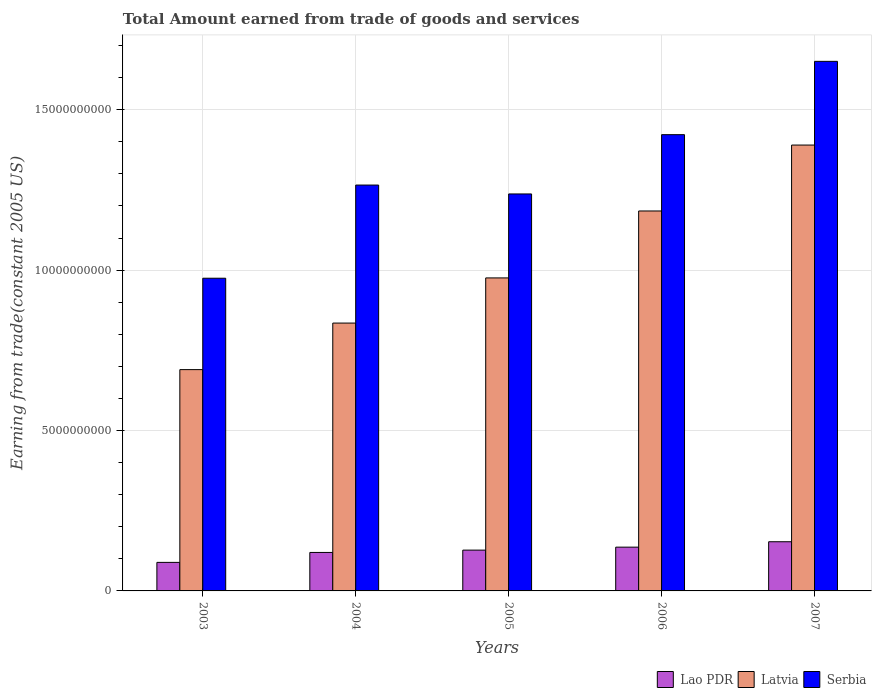How many different coloured bars are there?
Keep it short and to the point. 3. Are the number of bars on each tick of the X-axis equal?
Keep it short and to the point. Yes. How many bars are there on the 3rd tick from the left?
Give a very brief answer. 3. What is the total amount earned by trading goods and services in Serbia in 2003?
Your answer should be very brief. 9.75e+09. Across all years, what is the maximum total amount earned by trading goods and services in Latvia?
Give a very brief answer. 1.39e+1. Across all years, what is the minimum total amount earned by trading goods and services in Lao PDR?
Provide a succinct answer. 8.90e+08. What is the total total amount earned by trading goods and services in Latvia in the graph?
Give a very brief answer. 5.07e+1. What is the difference between the total amount earned by trading goods and services in Lao PDR in 2006 and that in 2007?
Provide a succinct answer. -1.69e+08. What is the difference between the total amount earned by trading goods and services in Serbia in 2007 and the total amount earned by trading goods and services in Latvia in 2003?
Make the answer very short. 9.61e+09. What is the average total amount earned by trading goods and services in Latvia per year?
Your answer should be very brief. 1.01e+1. In the year 2003, what is the difference between the total amount earned by trading goods and services in Latvia and total amount earned by trading goods and services in Serbia?
Give a very brief answer. -2.85e+09. What is the ratio of the total amount earned by trading goods and services in Lao PDR in 2003 to that in 2006?
Make the answer very short. 0.65. Is the total amount earned by trading goods and services in Serbia in 2004 less than that in 2006?
Your answer should be compact. Yes. Is the difference between the total amount earned by trading goods and services in Latvia in 2004 and 2005 greater than the difference between the total amount earned by trading goods and services in Serbia in 2004 and 2005?
Ensure brevity in your answer.  No. What is the difference between the highest and the second highest total amount earned by trading goods and services in Latvia?
Give a very brief answer. 2.05e+09. What is the difference between the highest and the lowest total amount earned by trading goods and services in Serbia?
Make the answer very short. 6.76e+09. In how many years, is the total amount earned by trading goods and services in Latvia greater than the average total amount earned by trading goods and services in Latvia taken over all years?
Offer a very short reply. 2. What does the 3rd bar from the left in 2004 represents?
Provide a short and direct response. Serbia. What does the 2nd bar from the right in 2007 represents?
Ensure brevity in your answer.  Latvia. Is it the case that in every year, the sum of the total amount earned by trading goods and services in Latvia and total amount earned by trading goods and services in Serbia is greater than the total amount earned by trading goods and services in Lao PDR?
Provide a succinct answer. Yes. How many bars are there?
Your answer should be very brief. 15. Are all the bars in the graph horizontal?
Your answer should be very brief. No. How many years are there in the graph?
Offer a very short reply. 5. What is the difference between two consecutive major ticks on the Y-axis?
Ensure brevity in your answer.  5.00e+09. Does the graph contain grids?
Give a very brief answer. Yes. What is the title of the graph?
Your response must be concise. Total Amount earned from trade of goods and services. What is the label or title of the Y-axis?
Provide a short and direct response. Earning from trade(constant 2005 US). What is the Earning from trade(constant 2005 US) of Lao PDR in 2003?
Provide a short and direct response. 8.90e+08. What is the Earning from trade(constant 2005 US) in Latvia in 2003?
Provide a short and direct response. 6.90e+09. What is the Earning from trade(constant 2005 US) of Serbia in 2003?
Give a very brief answer. 9.75e+09. What is the Earning from trade(constant 2005 US) in Lao PDR in 2004?
Keep it short and to the point. 1.20e+09. What is the Earning from trade(constant 2005 US) in Latvia in 2004?
Offer a very short reply. 8.35e+09. What is the Earning from trade(constant 2005 US) in Serbia in 2004?
Offer a terse response. 1.27e+1. What is the Earning from trade(constant 2005 US) in Lao PDR in 2005?
Provide a short and direct response. 1.27e+09. What is the Earning from trade(constant 2005 US) in Latvia in 2005?
Your answer should be compact. 9.76e+09. What is the Earning from trade(constant 2005 US) of Serbia in 2005?
Provide a short and direct response. 1.24e+1. What is the Earning from trade(constant 2005 US) of Lao PDR in 2006?
Your response must be concise. 1.36e+09. What is the Earning from trade(constant 2005 US) of Latvia in 2006?
Offer a terse response. 1.18e+1. What is the Earning from trade(constant 2005 US) of Serbia in 2006?
Offer a very short reply. 1.42e+1. What is the Earning from trade(constant 2005 US) of Lao PDR in 2007?
Make the answer very short. 1.53e+09. What is the Earning from trade(constant 2005 US) in Latvia in 2007?
Offer a terse response. 1.39e+1. What is the Earning from trade(constant 2005 US) of Serbia in 2007?
Make the answer very short. 1.65e+1. Across all years, what is the maximum Earning from trade(constant 2005 US) of Lao PDR?
Keep it short and to the point. 1.53e+09. Across all years, what is the maximum Earning from trade(constant 2005 US) of Latvia?
Your answer should be very brief. 1.39e+1. Across all years, what is the maximum Earning from trade(constant 2005 US) of Serbia?
Offer a terse response. 1.65e+1. Across all years, what is the minimum Earning from trade(constant 2005 US) of Lao PDR?
Your response must be concise. 8.90e+08. Across all years, what is the minimum Earning from trade(constant 2005 US) in Latvia?
Offer a very short reply. 6.90e+09. Across all years, what is the minimum Earning from trade(constant 2005 US) in Serbia?
Offer a terse response. 9.75e+09. What is the total Earning from trade(constant 2005 US) in Lao PDR in the graph?
Give a very brief answer. 6.26e+09. What is the total Earning from trade(constant 2005 US) of Latvia in the graph?
Give a very brief answer. 5.07e+1. What is the total Earning from trade(constant 2005 US) in Serbia in the graph?
Your answer should be very brief. 6.55e+1. What is the difference between the Earning from trade(constant 2005 US) of Lao PDR in 2003 and that in 2004?
Provide a short and direct response. -3.10e+08. What is the difference between the Earning from trade(constant 2005 US) in Latvia in 2003 and that in 2004?
Keep it short and to the point. -1.45e+09. What is the difference between the Earning from trade(constant 2005 US) of Serbia in 2003 and that in 2004?
Your answer should be very brief. -2.90e+09. What is the difference between the Earning from trade(constant 2005 US) of Lao PDR in 2003 and that in 2005?
Offer a terse response. -3.82e+08. What is the difference between the Earning from trade(constant 2005 US) in Latvia in 2003 and that in 2005?
Provide a short and direct response. -2.86e+09. What is the difference between the Earning from trade(constant 2005 US) in Serbia in 2003 and that in 2005?
Offer a terse response. -2.63e+09. What is the difference between the Earning from trade(constant 2005 US) of Lao PDR in 2003 and that in 2006?
Provide a succinct answer. -4.75e+08. What is the difference between the Earning from trade(constant 2005 US) of Latvia in 2003 and that in 2006?
Your answer should be very brief. -4.95e+09. What is the difference between the Earning from trade(constant 2005 US) of Serbia in 2003 and that in 2006?
Your answer should be very brief. -4.48e+09. What is the difference between the Earning from trade(constant 2005 US) in Lao PDR in 2003 and that in 2007?
Offer a terse response. -6.44e+08. What is the difference between the Earning from trade(constant 2005 US) of Latvia in 2003 and that in 2007?
Make the answer very short. -7.00e+09. What is the difference between the Earning from trade(constant 2005 US) in Serbia in 2003 and that in 2007?
Provide a short and direct response. -6.76e+09. What is the difference between the Earning from trade(constant 2005 US) of Lao PDR in 2004 and that in 2005?
Your answer should be very brief. -7.28e+07. What is the difference between the Earning from trade(constant 2005 US) of Latvia in 2004 and that in 2005?
Ensure brevity in your answer.  -1.41e+09. What is the difference between the Earning from trade(constant 2005 US) in Serbia in 2004 and that in 2005?
Keep it short and to the point. 2.77e+08. What is the difference between the Earning from trade(constant 2005 US) of Lao PDR in 2004 and that in 2006?
Offer a very short reply. -1.65e+08. What is the difference between the Earning from trade(constant 2005 US) in Latvia in 2004 and that in 2006?
Your answer should be very brief. -3.49e+09. What is the difference between the Earning from trade(constant 2005 US) of Serbia in 2004 and that in 2006?
Provide a succinct answer. -1.57e+09. What is the difference between the Earning from trade(constant 2005 US) in Lao PDR in 2004 and that in 2007?
Make the answer very short. -3.34e+08. What is the difference between the Earning from trade(constant 2005 US) in Latvia in 2004 and that in 2007?
Provide a short and direct response. -5.55e+09. What is the difference between the Earning from trade(constant 2005 US) of Serbia in 2004 and that in 2007?
Give a very brief answer. -3.86e+09. What is the difference between the Earning from trade(constant 2005 US) of Lao PDR in 2005 and that in 2006?
Give a very brief answer. -9.25e+07. What is the difference between the Earning from trade(constant 2005 US) of Latvia in 2005 and that in 2006?
Provide a succinct answer. -2.09e+09. What is the difference between the Earning from trade(constant 2005 US) in Serbia in 2005 and that in 2006?
Your answer should be very brief. -1.85e+09. What is the difference between the Earning from trade(constant 2005 US) of Lao PDR in 2005 and that in 2007?
Your response must be concise. -2.61e+08. What is the difference between the Earning from trade(constant 2005 US) in Latvia in 2005 and that in 2007?
Give a very brief answer. -4.14e+09. What is the difference between the Earning from trade(constant 2005 US) in Serbia in 2005 and that in 2007?
Give a very brief answer. -4.13e+09. What is the difference between the Earning from trade(constant 2005 US) in Lao PDR in 2006 and that in 2007?
Provide a succinct answer. -1.69e+08. What is the difference between the Earning from trade(constant 2005 US) of Latvia in 2006 and that in 2007?
Keep it short and to the point. -2.05e+09. What is the difference between the Earning from trade(constant 2005 US) of Serbia in 2006 and that in 2007?
Make the answer very short. -2.29e+09. What is the difference between the Earning from trade(constant 2005 US) of Lao PDR in 2003 and the Earning from trade(constant 2005 US) of Latvia in 2004?
Offer a very short reply. -7.46e+09. What is the difference between the Earning from trade(constant 2005 US) in Lao PDR in 2003 and the Earning from trade(constant 2005 US) in Serbia in 2004?
Offer a very short reply. -1.18e+1. What is the difference between the Earning from trade(constant 2005 US) in Latvia in 2003 and the Earning from trade(constant 2005 US) in Serbia in 2004?
Your answer should be very brief. -5.75e+09. What is the difference between the Earning from trade(constant 2005 US) of Lao PDR in 2003 and the Earning from trade(constant 2005 US) of Latvia in 2005?
Ensure brevity in your answer.  -8.87e+09. What is the difference between the Earning from trade(constant 2005 US) of Lao PDR in 2003 and the Earning from trade(constant 2005 US) of Serbia in 2005?
Offer a terse response. -1.15e+1. What is the difference between the Earning from trade(constant 2005 US) in Latvia in 2003 and the Earning from trade(constant 2005 US) in Serbia in 2005?
Provide a succinct answer. -5.48e+09. What is the difference between the Earning from trade(constant 2005 US) of Lao PDR in 2003 and the Earning from trade(constant 2005 US) of Latvia in 2006?
Offer a very short reply. -1.10e+1. What is the difference between the Earning from trade(constant 2005 US) in Lao PDR in 2003 and the Earning from trade(constant 2005 US) in Serbia in 2006?
Keep it short and to the point. -1.33e+1. What is the difference between the Earning from trade(constant 2005 US) of Latvia in 2003 and the Earning from trade(constant 2005 US) of Serbia in 2006?
Offer a very short reply. -7.32e+09. What is the difference between the Earning from trade(constant 2005 US) of Lao PDR in 2003 and the Earning from trade(constant 2005 US) of Latvia in 2007?
Ensure brevity in your answer.  -1.30e+1. What is the difference between the Earning from trade(constant 2005 US) of Lao PDR in 2003 and the Earning from trade(constant 2005 US) of Serbia in 2007?
Offer a terse response. -1.56e+1. What is the difference between the Earning from trade(constant 2005 US) in Latvia in 2003 and the Earning from trade(constant 2005 US) in Serbia in 2007?
Ensure brevity in your answer.  -9.61e+09. What is the difference between the Earning from trade(constant 2005 US) of Lao PDR in 2004 and the Earning from trade(constant 2005 US) of Latvia in 2005?
Ensure brevity in your answer.  -8.56e+09. What is the difference between the Earning from trade(constant 2005 US) in Lao PDR in 2004 and the Earning from trade(constant 2005 US) in Serbia in 2005?
Your answer should be compact. -1.12e+1. What is the difference between the Earning from trade(constant 2005 US) in Latvia in 2004 and the Earning from trade(constant 2005 US) in Serbia in 2005?
Offer a very short reply. -4.03e+09. What is the difference between the Earning from trade(constant 2005 US) of Lao PDR in 2004 and the Earning from trade(constant 2005 US) of Latvia in 2006?
Your response must be concise. -1.06e+1. What is the difference between the Earning from trade(constant 2005 US) in Lao PDR in 2004 and the Earning from trade(constant 2005 US) in Serbia in 2006?
Provide a succinct answer. -1.30e+1. What is the difference between the Earning from trade(constant 2005 US) in Latvia in 2004 and the Earning from trade(constant 2005 US) in Serbia in 2006?
Your answer should be compact. -5.87e+09. What is the difference between the Earning from trade(constant 2005 US) in Lao PDR in 2004 and the Earning from trade(constant 2005 US) in Latvia in 2007?
Provide a succinct answer. -1.27e+1. What is the difference between the Earning from trade(constant 2005 US) in Lao PDR in 2004 and the Earning from trade(constant 2005 US) in Serbia in 2007?
Offer a very short reply. -1.53e+1. What is the difference between the Earning from trade(constant 2005 US) in Latvia in 2004 and the Earning from trade(constant 2005 US) in Serbia in 2007?
Your response must be concise. -8.16e+09. What is the difference between the Earning from trade(constant 2005 US) in Lao PDR in 2005 and the Earning from trade(constant 2005 US) in Latvia in 2006?
Keep it short and to the point. -1.06e+1. What is the difference between the Earning from trade(constant 2005 US) in Lao PDR in 2005 and the Earning from trade(constant 2005 US) in Serbia in 2006?
Provide a succinct answer. -1.30e+1. What is the difference between the Earning from trade(constant 2005 US) in Latvia in 2005 and the Earning from trade(constant 2005 US) in Serbia in 2006?
Provide a succinct answer. -4.47e+09. What is the difference between the Earning from trade(constant 2005 US) of Lao PDR in 2005 and the Earning from trade(constant 2005 US) of Latvia in 2007?
Keep it short and to the point. -1.26e+1. What is the difference between the Earning from trade(constant 2005 US) of Lao PDR in 2005 and the Earning from trade(constant 2005 US) of Serbia in 2007?
Give a very brief answer. -1.52e+1. What is the difference between the Earning from trade(constant 2005 US) of Latvia in 2005 and the Earning from trade(constant 2005 US) of Serbia in 2007?
Make the answer very short. -6.75e+09. What is the difference between the Earning from trade(constant 2005 US) in Lao PDR in 2006 and the Earning from trade(constant 2005 US) in Latvia in 2007?
Give a very brief answer. -1.25e+1. What is the difference between the Earning from trade(constant 2005 US) of Lao PDR in 2006 and the Earning from trade(constant 2005 US) of Serbia in 2007?
Provide a succinct answer. -1.51e+1. What is the difference between the Earning from trade(constant 2005 US) in Latvia in 2006 and the Earning from trade(constant 2005 US) in Serbia in 2007?
Offer a terse response. -4.66e+09. What is the average Earning from trade(constant 2005 US) of Lao PDR per year?
Your answer should be compact. 1.25e+09. What is the average Earning from trade(constant 2005 US) in Latvia per year?
Offer a very short reply. 1.01e+1. What is the average Earning from trade(constant 2005 US) of Serbia per year?
Ensure brevity in your answer.  1.31e+1. In the year 2003, what is the difference between the Earning from trade(constant 2005 US) in Lao PDR and Earning from trade(constant 2005 US) in Latvia?
Your answer should be compact. -6.01e+09. In the year 2003, what is the difference between the Earning from trade(constant 2005 US) in Lao PDR and Earning from trade(constant 2005 US) in Serbia?
Offer a terse response. -8.86e+09. In the year 2003, what is the difference between the Earning from trade(constant 2005 US) in Latvia and Earning from trade(constant 2005 US) in Serbia?
Provide a short and direct response. -2.85e+09. In the year 2004, what is the difference between the Earning from trade(constant 2005 US) of Lao PDR and Earning from trade(constant 2005 US) of Latvia?
Your response must be concise. -7.15e+09. In the year 2004, what is the difference between the Earning from trade(constant 2005 US) in Lao PDR and Earning from trade(constant 2005 US) in Serbia?
Your response must be concise. -1.15e+1. In the year 2004, what is the difference between the Earning from trade(constant 2005 US) in Latvia and Earning from trade(constant 2005 US) in Serbia?
Your answer should be compact. -4.30e+09. In the year 2005, what is the difference between the Earning from trade(constant 2005 US) of Lao PDR and Earning from trade(constant 2005 US) of Latvia?
Provide a succinct answer. -8.49e+09. In the year 2005, what is the difference between the Earning from trade(constant 2005 US) of Lao PDR and Earning from trade(constant 2005 US) of Serbia?
Offer a very short reply. -1.11e+1. In the year 2005, what is the difference between the Earning from trade(constant 2005 US) in Latvia and Earning from trade(constant 2005 US) in Serbia?
Make the answer very short. -2.62e+09. In the year 2006, what is the difference between the Earning from trade(constant 2005 US) of Lao PDR and Earning from trade(constant 2005 US) of Latvia?
Your answer should be compact. -1.05e+1. In the year 2006, what is the difference between the Earning from trade(constant 2005 US) in Lao PDR and Earning from trade(constant 2005 US) in Serbia?
Your answer should be compact. -1.29e+1. In the year 2006, what is the difference between the Earning from trade(constant 2005 US) in Latvia and Earning from trade(constant 2005 US) in Serbia?
Provide a short and direct response. -2.38e+09. In the year 2007, what is the difference between the Earning from trade(constant 2005 US) of Lao PDR and Earning from trade(constant 2005 US) of Latvia?
Your response must be concise. -1.24e+1. In the year 2007, what is the difference between the Earning from trade(constant 2005 US) of Lao PDR and Earning from trade(constant 2005 US) of Serbia?
Offer a terse response. -1.50e+1. In the year 2007, what is the difference between the Earning from trade(constant 2005 US) in Latvia and Earning from trade(constant 2005 US) in Serbia?
Ensure brevity in your answer.  -2.61e+09. What is the ratio of the Earning from trade(constant 2005 US) of Lao PDR in 2003 to that in 2004?
Provide a short and direct response. 0.74. What is the ratio of the Earning from trade(constant 2005 US) of Latvia in 2003 to that in 2004?
Ensure brevity in your answer.  0.83. What is the ratio of the Earning from trade(constant 2005 US) of Serbia in 2003 to that in 2004?
Offer a very short reply. 0.77. What is the ratio of the Earning from trade(constant 2005 US) in Lao PDR in 2003 to that in 2005?
Your response must be concise. 0.7. What is the ratio of the Earning from trade(constant 2005 US) of Latvia in 2003 to that in 2005?
Your answer should be very brief. 0.71. What is the ratio of the Earning from trade(constant 2005 US) of Serbia in 2003 to that in 2005?
Ensure brevity in your answer.  0.79. What is the ratio of the Earning from trade(constant 2005 US) of Lao PDR in 2003 to that in 2006?
Provide a succinct answer. 0.65. What is the ratio of the Earning from trade(constant 2005 US) of Latvia in 2003 to that in 2006?
Provide a succinct answer. 0.58. What is the ratio of the Earning from trade(constant 2005 US) of Serbia in 2003 to that in 2006?
Ensure brevity in your answer.  0.69. What is the ratio of the Earning from trade(constant 2005 US) of Lao PDR in 2003 to that in 2007?
Provide a succinct answer. 0.58. What is the ratio of the Earning from trade(constant 2005 US) in Latvia in 2003 to that in 2007?
Provide a short and direct response. 0.5. What is the ratio of the Earning from trade(constant 2005 US) in Serbia in 2003 to that in 2007?
Give a very brief answer. 0.59. What is the ratio of the Earning from trade(constant 2005 US) of Lao PDR in 2004 to that in 2005?
Ensure brevity in your answer.  0.94. What is the ratio of the Earning from trade(constant 2005 US) in Latvia in 2004 to that in 2005?
Provide a short and direct response. 0.86. What is the ratio of the Earning from trade(constant 2005 US) in Serbia in 2004 to that in 2005?
Offer a terse response. 1.02. What is the ratio of the Earning from trade(constant 2005 US) in Lao PDR in 2004 to that in 2006?
Your answer should be very brief. 0.88. What is the ratio of the Earning from trade(constant 2005 US) in Latvia in 2004 to that in 2006?
Ensure brevity in your answer.  0.7. What is the ratio of the Earning from trade(constant 2005 US) of Serbia in 2004 to that in 2006?
Make the answer very short. 0.89. What is the ratio of the Earning from trade(constant 2005 US) in Lao PDR in 2004 to that in 2007?
Your answer should be very brief. 0.78. What is the ratio of the Earning from trade(constant 2005 US) in Latvia in 2004 to that in 2007?
Ensure brevity in your answer.  0.6. What is the ratio of the Earning from trade(constant 2005 US) of Serbia in 2004 to that in 2007?
Provide a succinct answer. 0.77. What is the ratio of the Earning from trade(constant 2005 US) in Lao PDR in 2005 to that in 2006?
Offer a very short reply. 0.93. What is the ratio of the Earning from trade(constant 2005 US) of Latvia in 2005 to that in 2006?
Give a very brief answer. 0.82. What is the ratio of the Earning from trade(constant 2005 US) in Serbia in 2005 to that in 2006?
Ensure brevity in your answer.  0.87. What is the ratio of the Earning from trade(constant 2005 US) in Lao PDR in 2005 to that in 2007?
Give a very brief answer. 0.83. What is the ratio of the Earning from trade(constant 2005 US) of Latvia in 2005 to that in 2007?
Give a very brief answer. 0.7. What is the ratio of the Earning from trade(constant 2005 US) in Serbia in 2005 to that in 2007?
Give a very brief answer. 0.75. What is the ratio of the Earning from trade(constant 2005 US) in Lao PDR in 2006 to that in 2007?
Ensure brevity in your answer.  0.89. What is the ratio of the Earning from trade(constant 2005 US) of Latvia in 2006 to that in 2007?
Offer a very short reply. 0.85. What is the ratio of the Earning from trade(constant 2005 US) in Serbia in 2006 to that in 2007?
Your answer should be compact. 0.86. What is the difference between the highest and the second highest Earning from trade(constant 2005 US) of Lao PDR?
Your response must be concise. 1.69e+08. What is the difference between the highest and the second highest Earning from trade(constant 2005 US) in Latvia?
Offer a very short reply. 2.05e+09. What is the difference between the highest and the second highest Earning from trade(constant 2005 US) of Serbia?
Your answer should be compact. 2.29e+09. What is the difference between the highest and the lowest Earning from trade(constant 2005 US) in Lao PDR?
Make the answer very short. 6.44e+08. What is the difference between the highest and the lowest Earning from trade(constant 2005 US) in Latvia?
Offer a very short reply. 7.00e+09. What is the difference between the highest and the lowest Earning from trade(constant 2005 US) of Serbia?
Your response must be concise. 6.76e+09. 